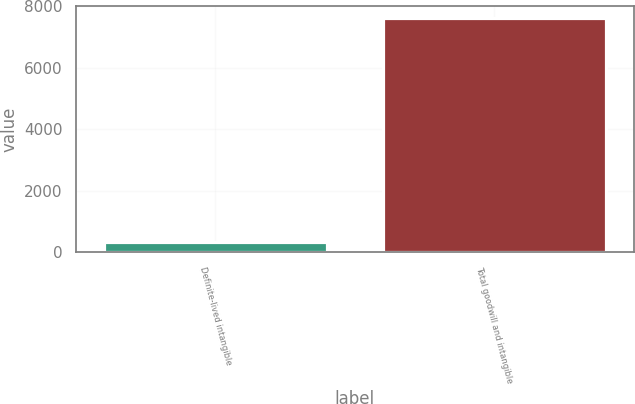Convert chart to OTSL. <chart><loc_0><loc_0><loc_500><loc_500><bar_chart><fcel>Definite-lived intangible<fcel>Total goodwill and intangible<nl><fcel>329.1<fcel>7627.7<nl></chart> 